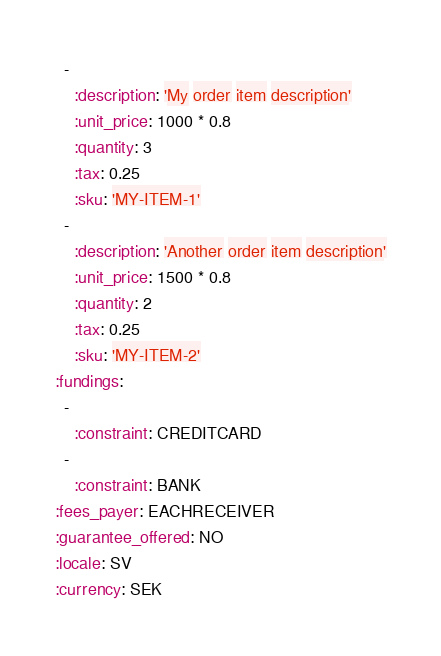Convert code to text. <code><loc_0><loc_0><loc_500><loc_500><_YAML_>  -
    :description: 'My order item description'
    :unit_price: 1000 * 0.8
    :quantity: 3
    :tax: 0.25
    :sku: 'MY-ITEM-1'
  -
    :description: 'Another order item description'
    :unit_price: 1500 * 0.8
    :quantity: 2
    :tax: 0.25
    :sku: 'MY-ITEM-2'
:fundings:
  -
    :constraint: CREDITCARD
  -
    :constraint: BANK
:fees_payer: EACHRECEIVER
:guarantee_offered: NO
:locale: SV
:currency: SEK
</code> 